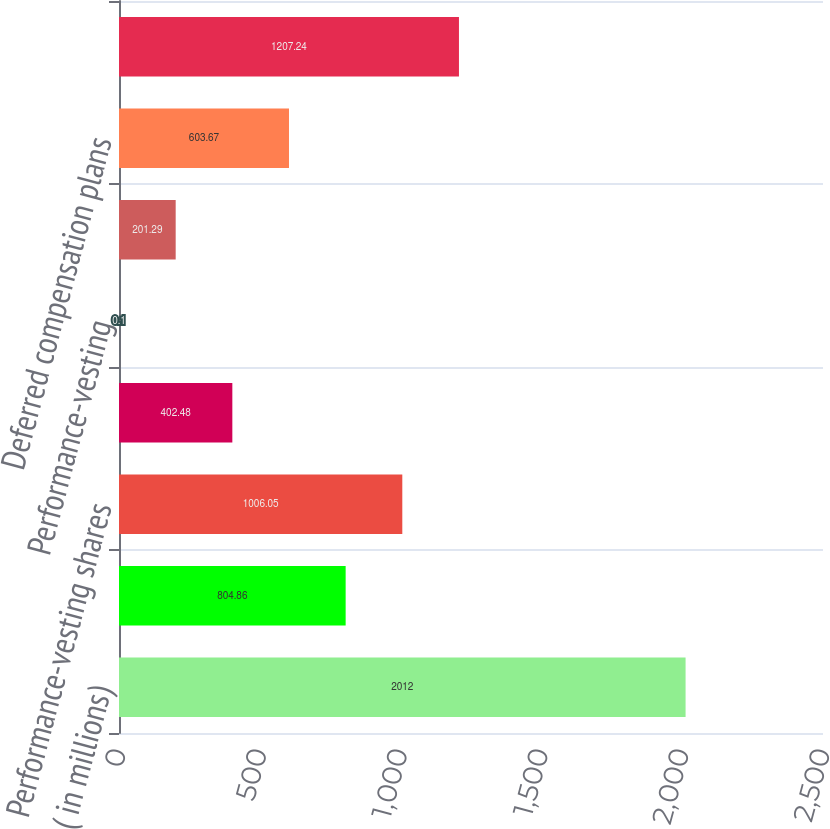Convert chart. <chart><loc_0><loc_0><loc_500><loc_500><bar_chart><fcel>( in millions)<fcel>Stock option and appreciation<fcel>Performance-vesting shares<fcel>Performance-vesting units<fcel>Performance-vesting<fcel>Employee stock purchase plan<fcel>Deferred compensation plans<fcel>Total stock-based compensation<nl><fcel>2012<fcel>804.86<fcel>1006.05<fcel>402.48<fcel>0.1<fcel>201.29<fcel>603.67<fcel>1207.24<nl></chart> 